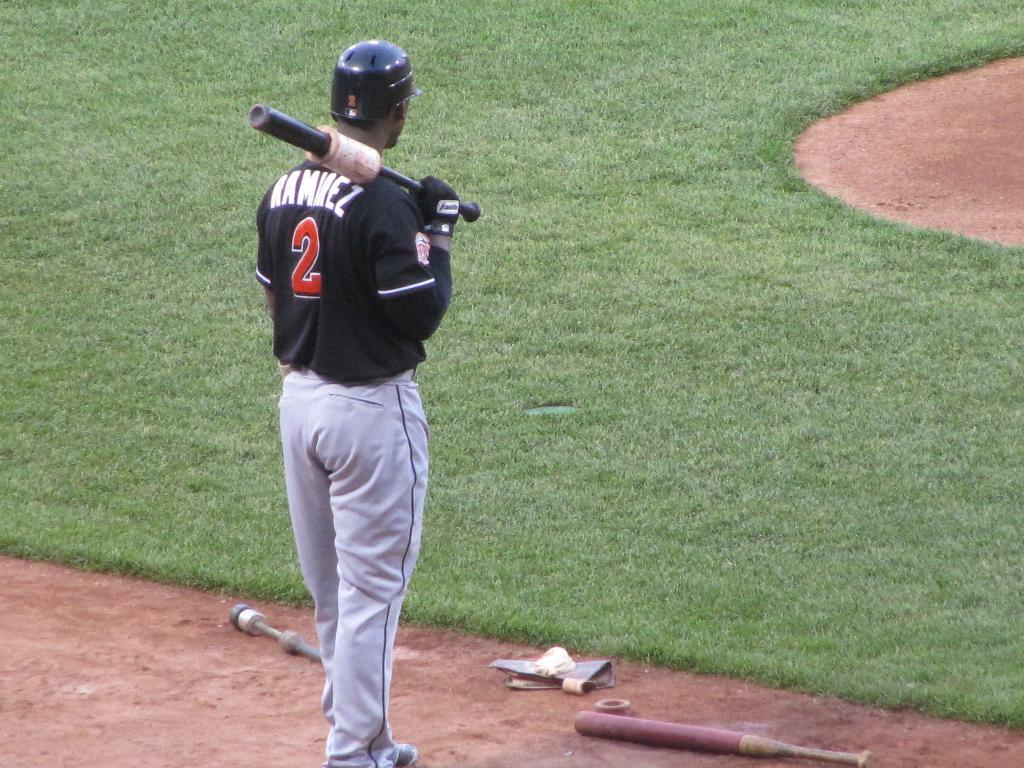<image>
Provide a brief description of the given image. a baseball player with a black shirt and the number 2 on his back is holding his bat. 